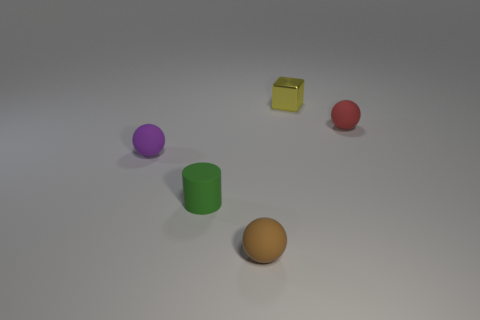Add 2 small green matte objects. How many objects exist? 7 Subtract all spheres. How many objects are left? 2 Add 1 red balls. How many red balls are left? 2 Add 5 red things. How many red things exist? 6 Subtract 0 green cubes. How many objects are left? 5 Subtract all cyan shiny cylinders. Subtract all tiny red spheres. How many objects are left? 4 